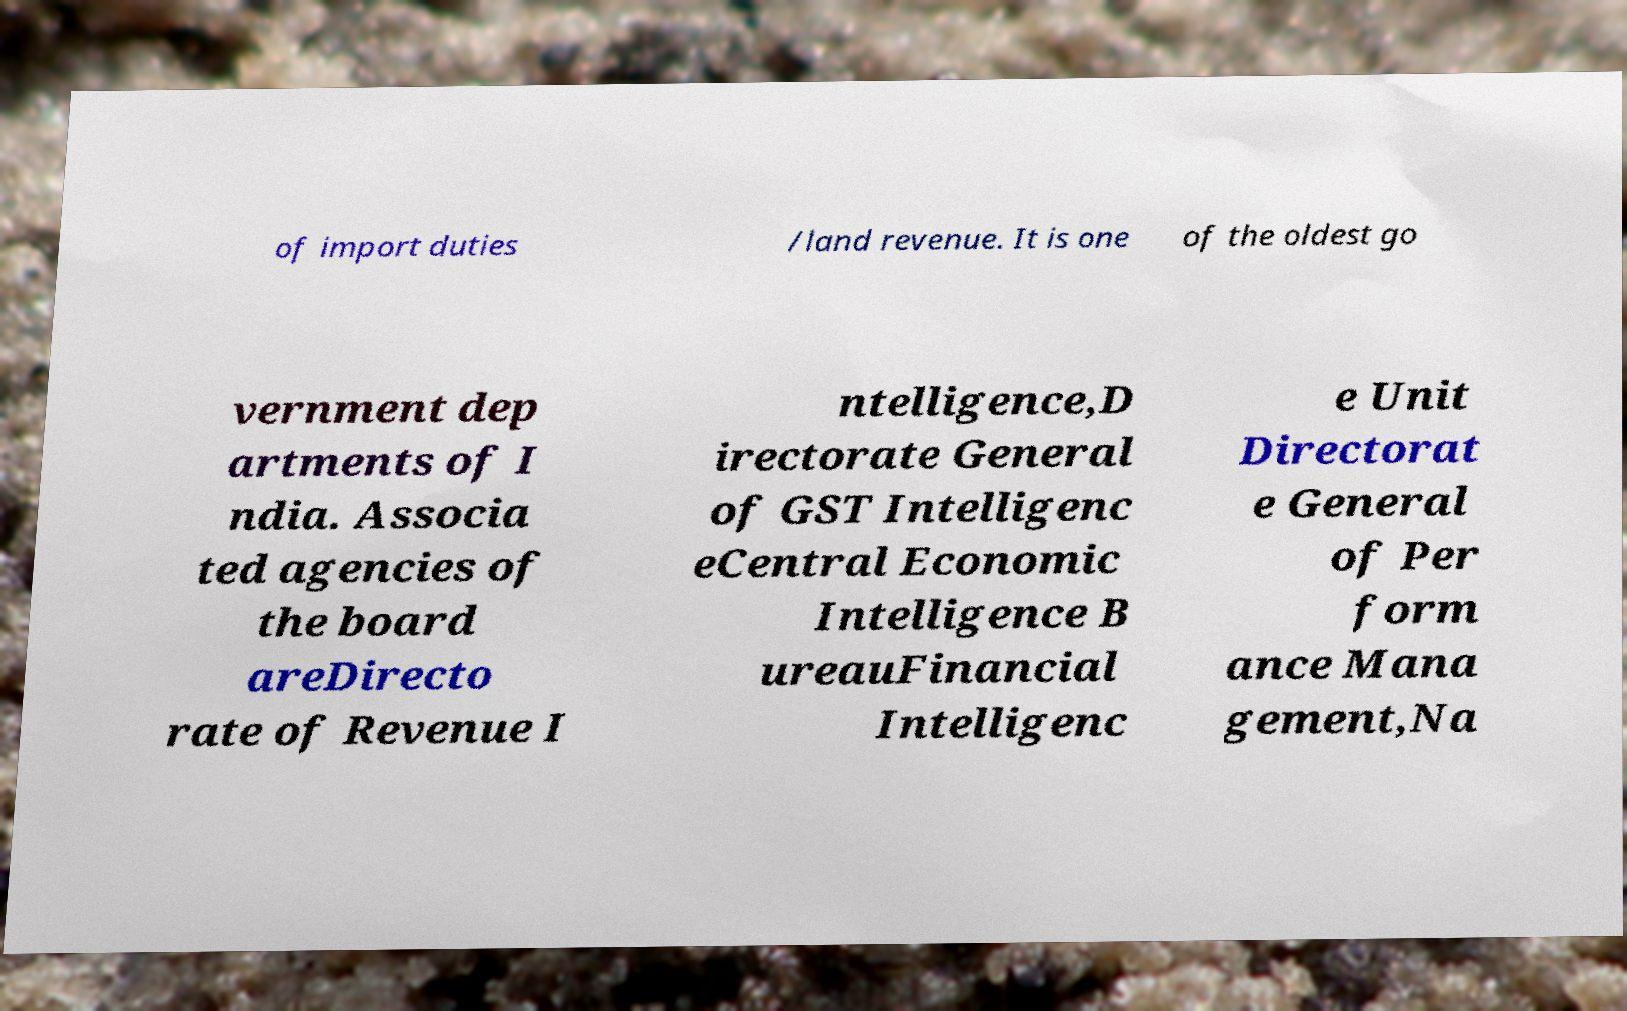Could you assist in decoding the text presented in this image and type it out clearly? of import duties /land revenue. It is one of the oldest go vernment dep artments of I ndia. Associa ted agencies of the board areDirecto rate of Revenue I ntelligence,D irectorate General of GST Intelligenc eCentral Economic Intelligence B ureauFinancial Intelligenc e Unit Directorat e General of Per form ance Mana gement,Na 